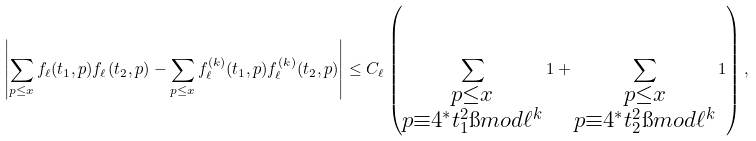<formula> <loc_0><loc_0><loc_500><loc_500>\left | \sum _ { p \leq x } f _ { \ell } ( t _ { 1 } , p ) f _ { \ell } ( t _ { 2 } , p ) - \sum _ { p \leq x } f _ { \ell } ^ { ( k ) } ( t _ { 1 } , p ) f _ { \ell } ^ { ( k ) } ( t _ { 2 } , p ) \right | \leq C _ { \ell } \left ( \sum _ { \substack { { p \leq x } \\ { p \equiv 4 ^ { * } t _ { 1 } ^ { 2 } \i m o d { \ell ^ { k } } } } } 1 + \sum _ { \substack { { p \leq x } \\ { p \equiv 4 ^ { * } t _ { 2 } ^ { 2 } \i m o d { \ell ^ { k } } } } } 1 \right ) ,</formula> 